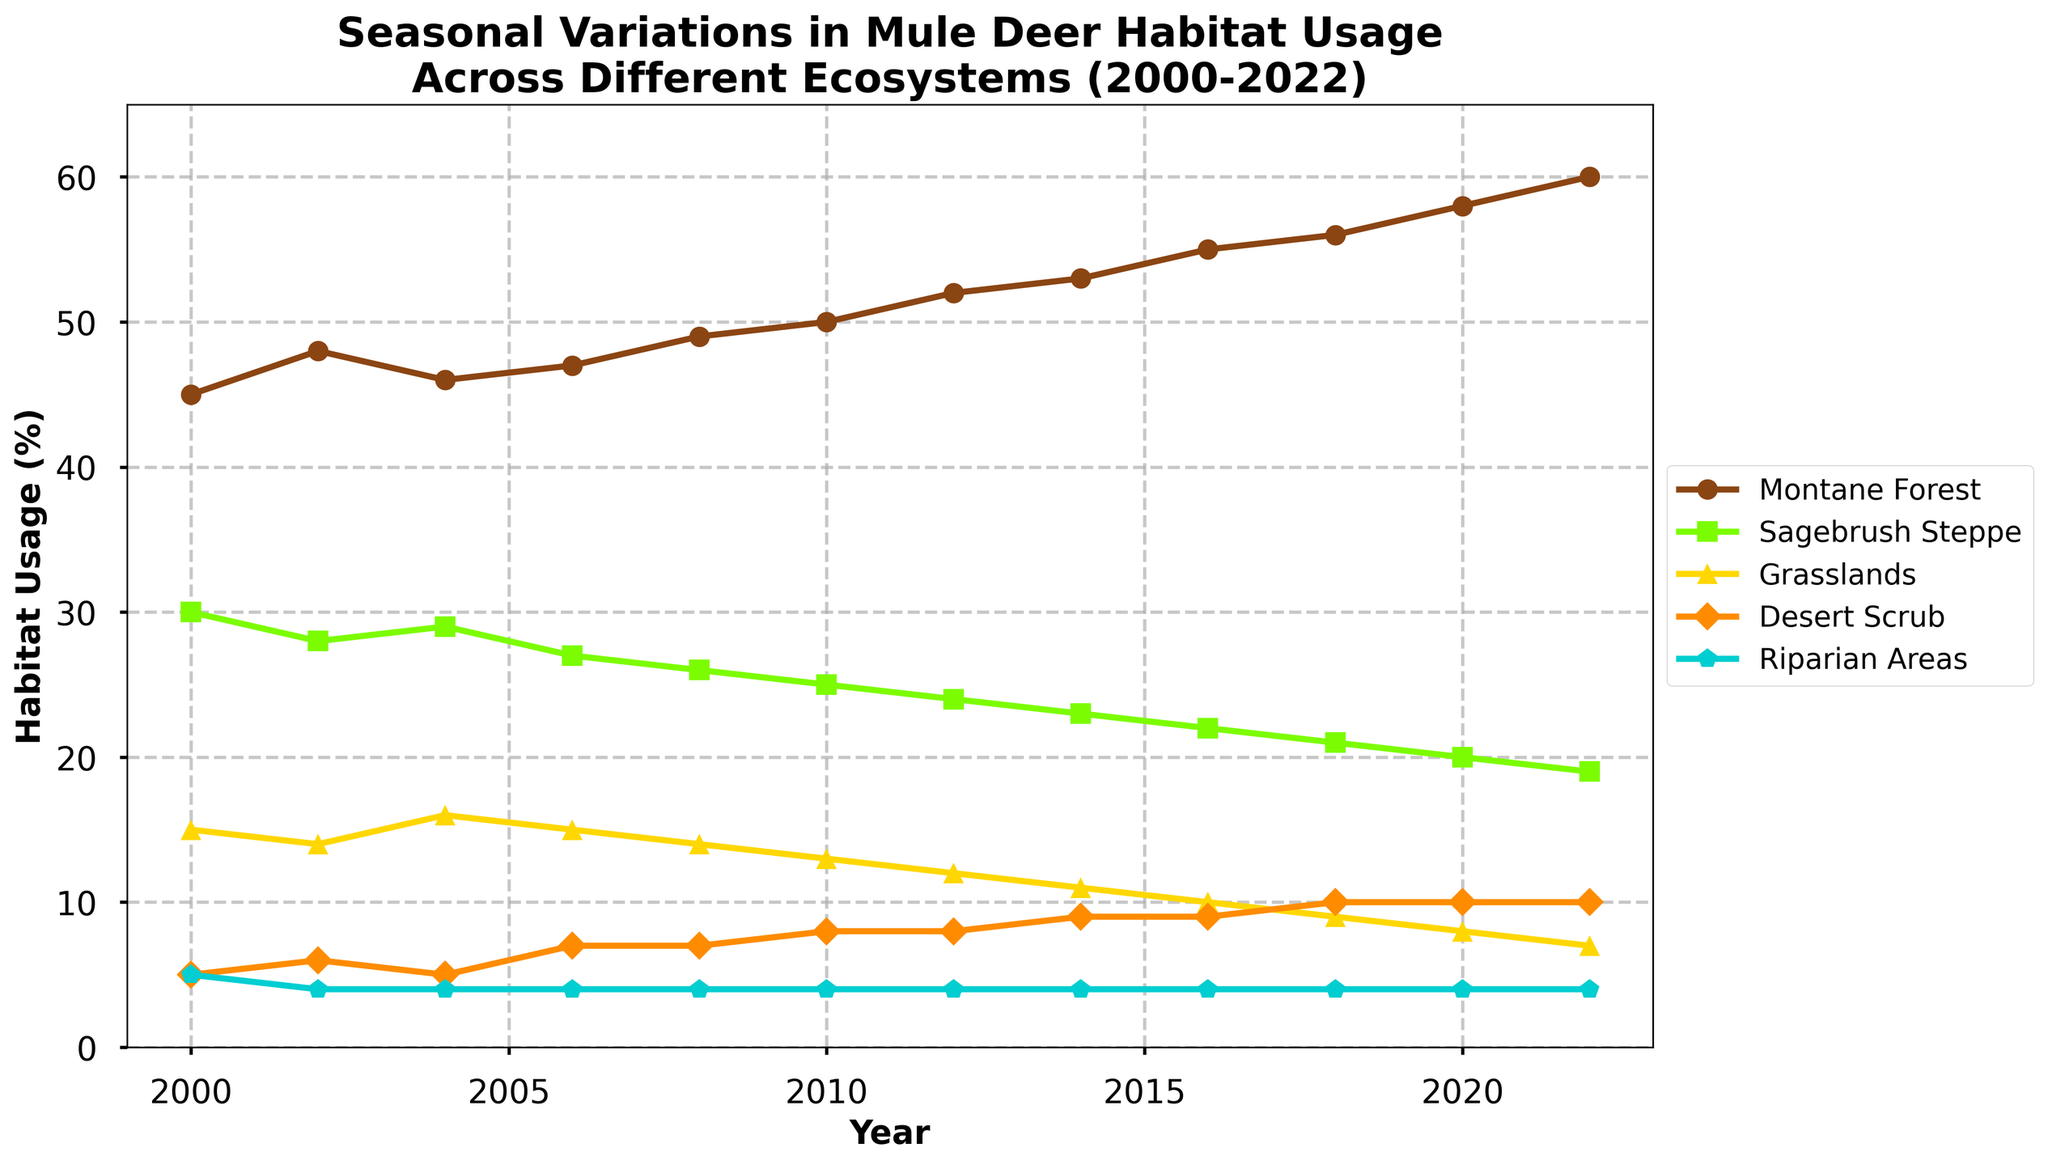When did the Montane Forest habitat usage surpass 50%? The Montane Forest line passes the 50% mark between 2010 and 2012. By checking the data table or the plot, you can see it reached 50% in 2010 and kept increasing in the following years.
Answer: 2010 Which ecosystem had a steady habitat usage of 4% throughout the years? By observing the horizontal lines in the figure, the Riparian Areas line remains at the 4% mark consistently from 2000 to 2022.
Answer: Riparian Areas What was the trend in habitat usage for the Sagebrush Steppe ecosystem from 2000 to 2022? The plot shows that the Sagebrush Steppe habitat usage declines continuously from 30% in 2000 to 19% in 2022.
Answer: Declining By how much did the Desert Scrub habitat usage increase from 2000 to 2022? From the plot or data, Desert Scrub usage was 5% in 2000 and increased to 10% in 2022. The difference is 10% - 5% = 5%.
Answer: 5% In what year was the usage of Grasslands at its peak? The highest point in the Grasslands line is at 2004, where it reaches 16%.
Answer: 2004 Compare the habitat usage change between Montane Forest and Grasslands from 2000 to 2022. Which increased by a greater percentage? Montane Forest increased from 45% to 60%, an increase of 15%. Grasslands decreased from 15% to 7%, a decrease of 8%. Clearly, Montane Forest had a larger increase.
Answer: Montane Forest Which ecosystem shows the smallest variation in habitat usage over the period? Riparian Areas consistently remain at 4% with no variation, as seen from the flat line in the plot.
Answer: Riparian Areas What is the sum of habitat usage percentages for the year 2006 across all ecosystems? Referring to the data for 2006: Montane Forest (47%), Sagebrush Steppe (27%), Grasslands (15%), Desert Scrub (7%), Riparian Areas (4%). The sum is 47 + 27 + 15 + 7 + 4 = 100%.
Answer: 100% In which years did the Montane Forest habitat have its steepest incline? Observing the plot, the Montane Forest line has the steepest incline between 2014 and 2016, where it jumps from 53% to 55%.
Answer: 2014-2016 What change did the Grasslands ecosystem experience between 2018 and 2022? From the plot, Grasslands dropped from 9% in 2018 to 7% in 2022, indicating a decrease.
Answer: Decrease 